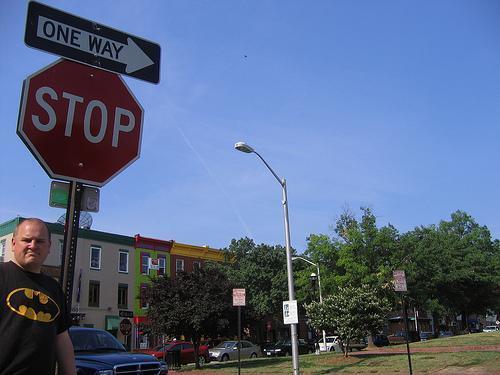How many people are standing under the stop sign?
Give a very brief answer. 1. 